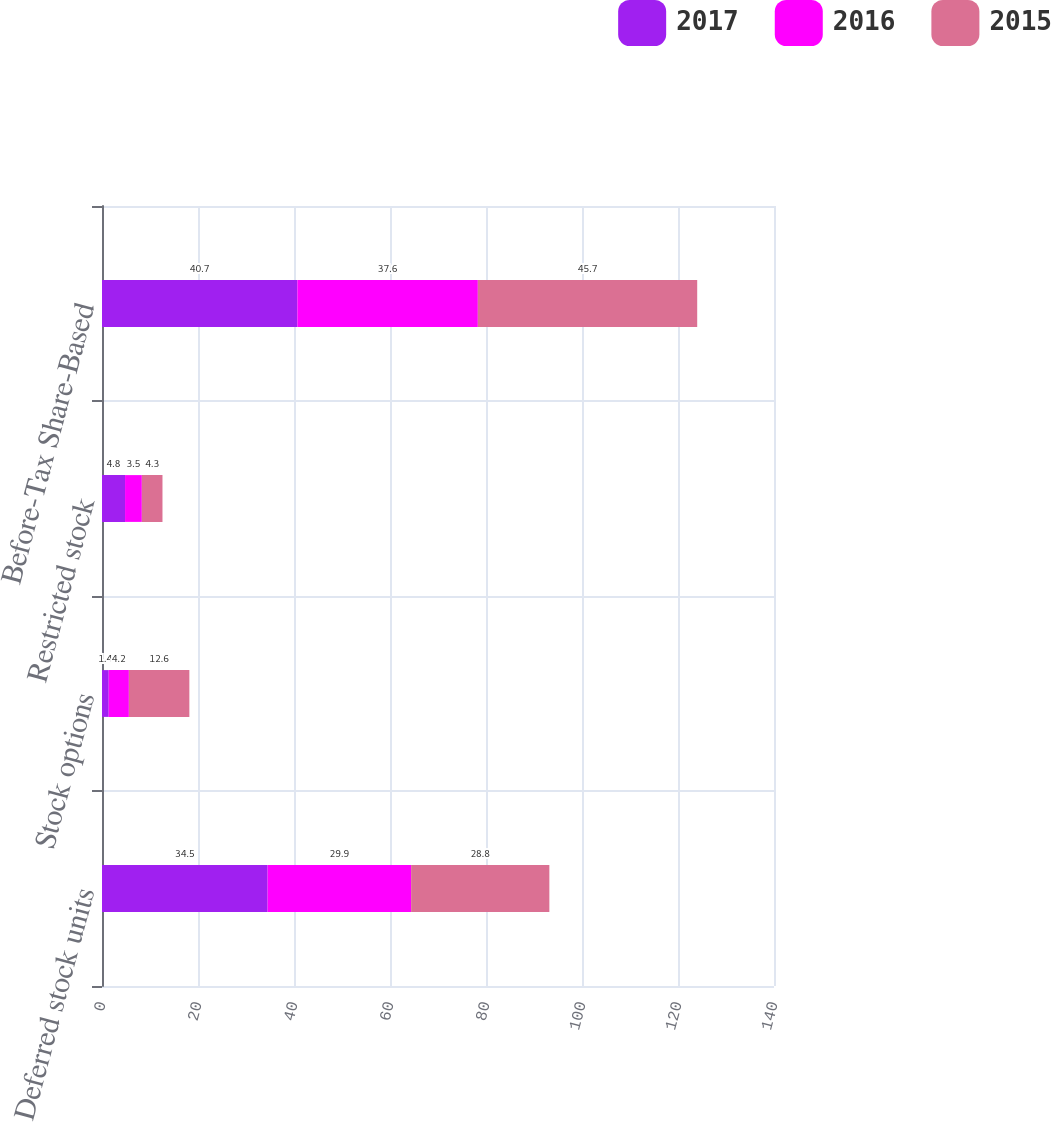Convert chart. <chart><loc_0><loc_0><loc_500><loc_500><stacked_bar_chart><ecel><fcel>Deferred stock units<fcel>Stock options<fcel>Restricted stock<fcel>Before-Tax Share-Based<nl><fcel>2017<fcel>34.5<fcel>1.4<fcel>4.8<fcel>40.7<nl><fcel>2016<fcel>29.9<fcel>4.2<fcel>3.5<fcel>37.6<nl><fcel>2015<fcel>28.8<fcel>12.6<fcel>4.3<fcel>45.7<nl></chart> 